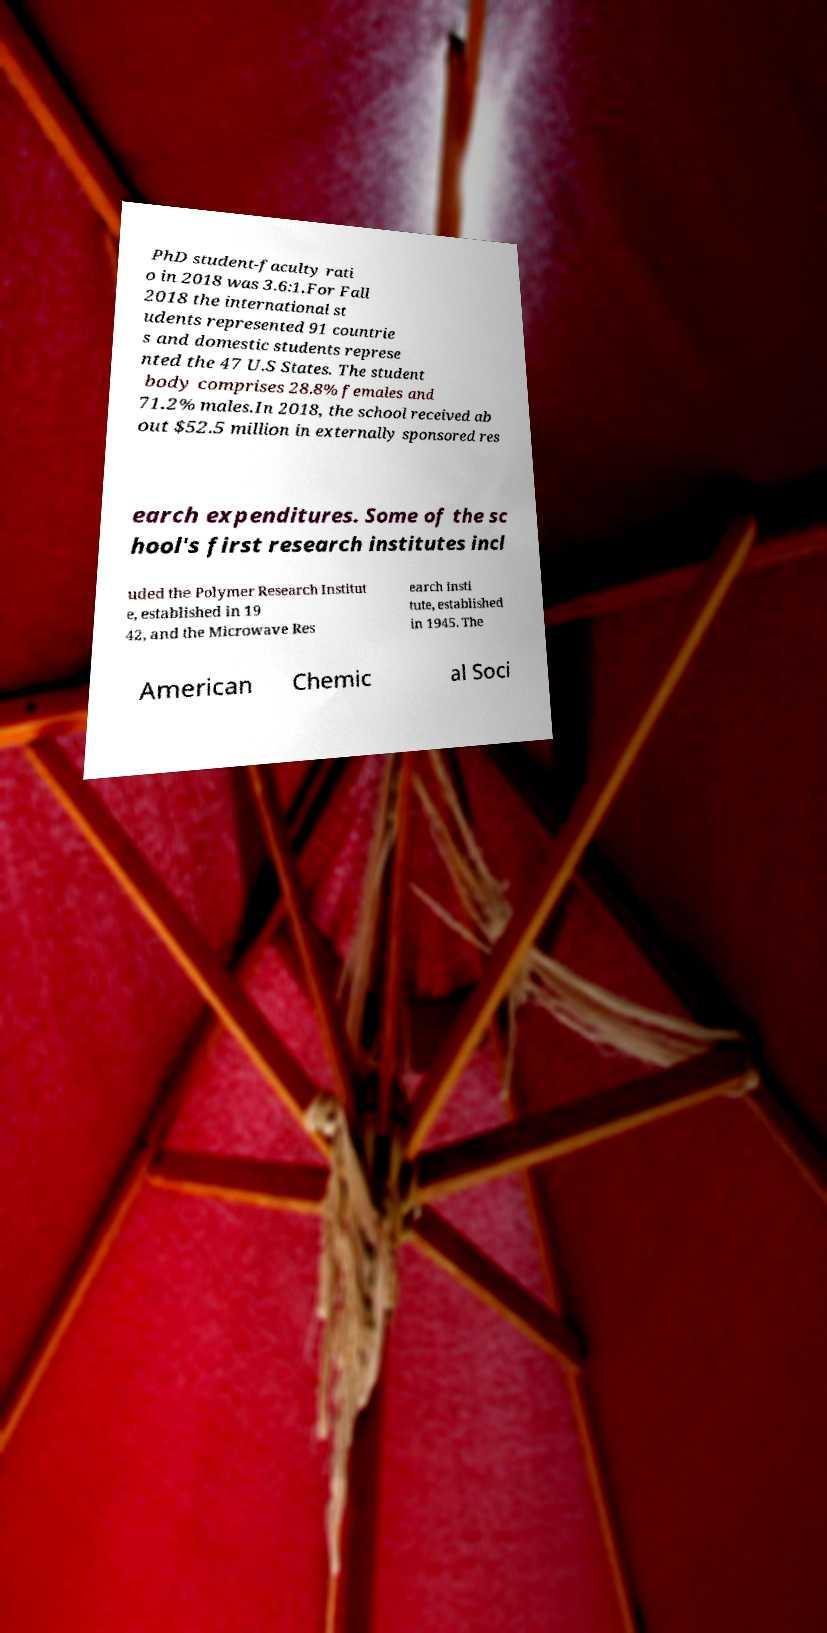Could you assist in decoding the text presented in this image and type it out clearly? PhD student-faculty rati o in 2018 was 3.6:1.For Fall 2018 the international st udents represented 91 countrie s and domestic students represe nted the 47 U.S States. The student body comprises 28.8% females and 71.2% males.In 2018, the school received ab out $52.5 million in externally sponsored res earch expenditures. Some of the sc hool's first research institutes incl uded the Polymer Research Institut e, established in 19 42, and the Microwave Res earch Insti tute, established in 1945. The American Chemic al Soci 